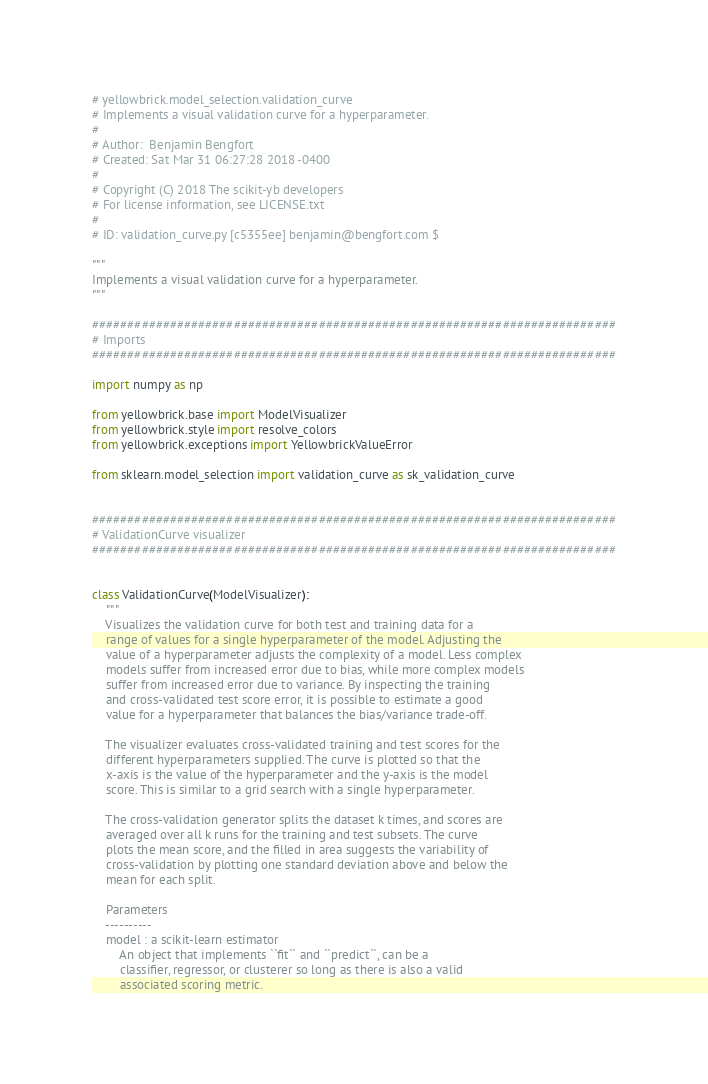Convert code to text. <code><loc_0><loc_0><loc_500><loc_500><_Python_># yellowbrick.model_selection.validation_curve
# Implements a visual validation curve for a hyperparameter.
#
# Author:  Benjamin Bengfort
# Created: Sat Mar 31 06:27:28 2018 -0400
#
# Copyright (C) 2018 The scikit-yb developers
# For license information, see LICENSE.txt
#
# ID: validation_curve.py [c5355ee] benjamin@bengfort.com $

"""
Implements a visual validation curve for a hyperparameter.
"""

##########################################################################
# Imports
##########################################################################

import numpy as np

from yellowbrick.base import ModelVisualizer
from yellowbrick.style import resolve_colors
from yellowbrick.exceptions import YellowbrickValueError

from sklearn.model_selection import validation_curve as sk_validation_curve


##########################################################################
# ValidationCurve visualizer
##########################################################################


class ValidationCurve(ModelVisualizer):
    """
    Visualizes the validation curve for both test and training data for a
    range of values for a single hyperparameter of the model. Adjusting the
    value of a hyperparameter adjusts the complexity of a model. Less complex
    models suffer from increased error due to bias, while more complex models
    suffer from increased error due to variance. By inspecting the training
    and cross-validated test score error, it is possible to estimate a good
    value for a hyperparameter that balances the bias/variance trade-off.

    The visualizer evaluates cross-validated training and test scores for the
    different hyperparameters supplied. The curve is plotted so that the
    x-axis is the value of the hyperparameter and the y-axis is the model
    score. This is similar to a grid search with a single hyperparameter.

    The cross-validation generator splits the dataset k times, and scores are
    averaged over all k runs for the training and test subsets. The curve
    plots the mean score, and the filled in area suggests the variability of
    cross-validation by plotting one standard deviation above and below the
    mean for each split.

    Parameters
    ----------
    model : a scikit-learn estimator
        An object that implements ``fit`` and ``predict``, can be a
        classifier, regressor, or clusterer so long as there is also a valid
        associated scoring metric.
</code> 